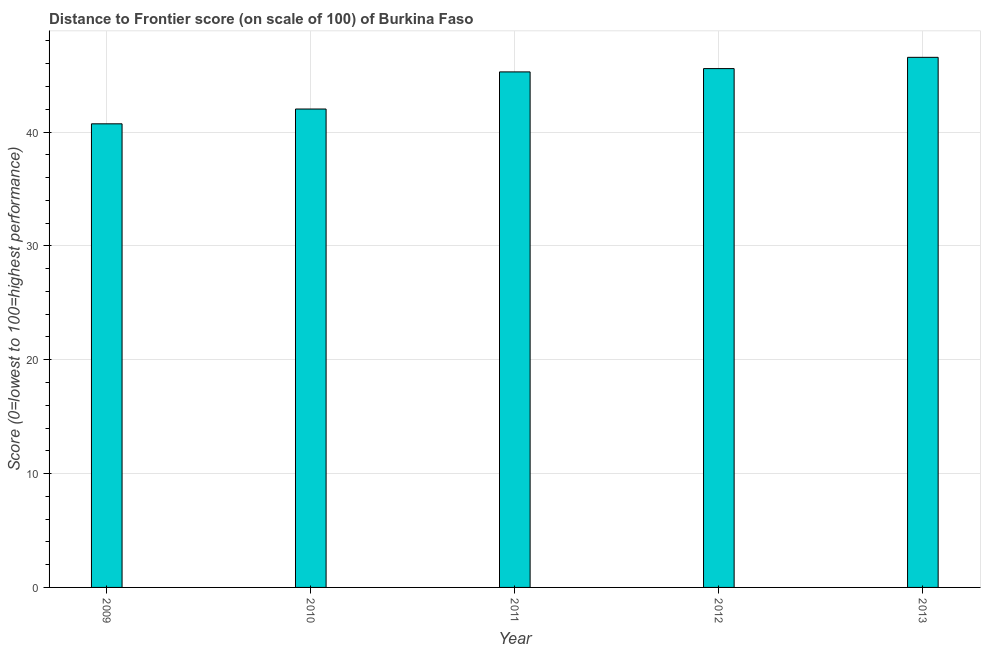Does the graph contain any zero values?
Your answer should be very brief. No. Does the graph contain grids?
Give a very brief answer. Yes. What is the title of the graph?
Keep it short and to the point. Distance to Frontier score (on scale of 100) of Burkina Faso. What is the label or title of the X-axis?
Provide a short and direct response. Year. What is the label or title of the Y-axis?
Give a very brief answer. Score (0=lowest to 100=highest performance). What is the distance to frontier score in 2013?
Give a very brief answer. 46.56. Across all years, what is the maximum distance to frontier score?
Your answer should be very brief. 46.56. Across all years, what is the minimum distance to frontier score?
Offer a very short reply. 40.72. In which year was the distance to frontier score minimum?
Provide a short and direct response. 2009. What is the sum of the distance to frontier score?
Your response must be concise. 220.15. What is the difference between the distance to frontier score in 2012 and 2013?
Provide a short and direct response. -0.99. What is the average distance to frontier score per year?
Give a very brief answer. 44.03. What is the median distance to frontier score?
Keep it short and to the point. 45.28. In how many years, is the distance to frontier score greater than 10 ?
Keep it short and to the point. 5. Do a majority of the years between 2011 and 2012 (inclusive) have distance to frontier score greater than 6 ?
Give a very brief answer. Yes. What is the ratio of the distance to frontier score in 2010 to that in 2012?
Keep it short and to the point. 0.92. Is the distance to frontier score in 2011 less than that in 2012?
Your answer should be compact. Yes. What is the difference between the highest and the second highest distance to frontier score?
Give a very brief answer. 0.99. Is the sum of the distance to frontier score in 2012 and 2013 greater than the maximum distance to frontier score across all years?
Provide a succinct answer. Yes. What is the difference between the highest and the lowest distance to frontier score?
Your answer should be very brief. 5.84. Are all the bars in the graph horizontal?
Make the answer very short. No. What is the difference between two consecutive major ticks on the Y-axis?
Your response must be concise. 10. What is the Score (0=lowest to 100=highest performance) in 2009?
Offer a terse response. 40.72. What is the Score (0=lowest to 100=highest performance) in 2010?
Provide a succinct answer. 42.02. What is the Score (0=lowest to 100=highest performance) of 2011?
Your answer should be compact. 45.28. What is the Score (0=lowest to 100=highest performance) in 2012?
Your response must be concise. 45.57. What is the Score (0=lowest to 100=highest performance) of 2013?
Your response must be concise. 46.56. What is the difference between the Score (0=lowest to 100=highest performance) in 2009 and 2010?
Make the answer very short. -1.3. What is the difference between the Score (0=lowest to 100=highest performance) in 2009 and 2011?
Make the answer very short. -4.56. What is the difference between the Score (0=lowest to 100=highest performance) in 2009 and 2012?
Provide a succinct answer. -4.85. What is the difference between the Score (0=lowest to 100=highest performance) in 2009 and 2013?
Provide a succinct answer. -5.84. What is the difference between the Score (0=lowest to 100=highest performance) in 2010 and 2011?
Your response must be concise. -3.26. What is the difference between the Score (0=lowest to 100=highest performance) in 2010 and 2012?
Offer a terse response. -3.55. What is the difference between the Score (0=lowest to 100=highest performance) in 2010 and 2013?
Keep it short and to the point. -4.54. What is the difference between the Score (0=lowest to 100=highest performance) in 2011 and 2012?
Provide a short and direct response. -0.29. What is the difference between the Score (0=lowest to 100=highest performance) in 2011 and 2013?
Your response must be concise. -1.28. What is the difference between the Score (0=lowest to 100=highest performance) in 2012 and 2013?
Your response must be concise. -0.99. What is the ratio of the Score (0=lowest to 100=highest performance) in 2009 to that in 2011?
Your answer should be very brief. 0.9. What is the ratio of the Score (0=lowest to 100=highest performance) in 2009 to that in 2012?
Provide a succinct answer. 0.89. What is the ratio of the Score (0=lowest to 100=highest performance) in 2010 to that in 2011?
Give a very brief answer. 0.93. What is the ratio of the Score (0=lowest to 100=highest performance) in 2010 to that in 2012?
Keep it short and to the point. 0.92. What is the ratio of the Score (0=lowest to 100=highest performance) in 2010 to that in 2013?
Ensure brevity in your answer.  0.9. What is the ratio of the Score (0=lowest to 100=highest performance) in 2012 to that in 2013?
Offer a terse response. 0.98. 